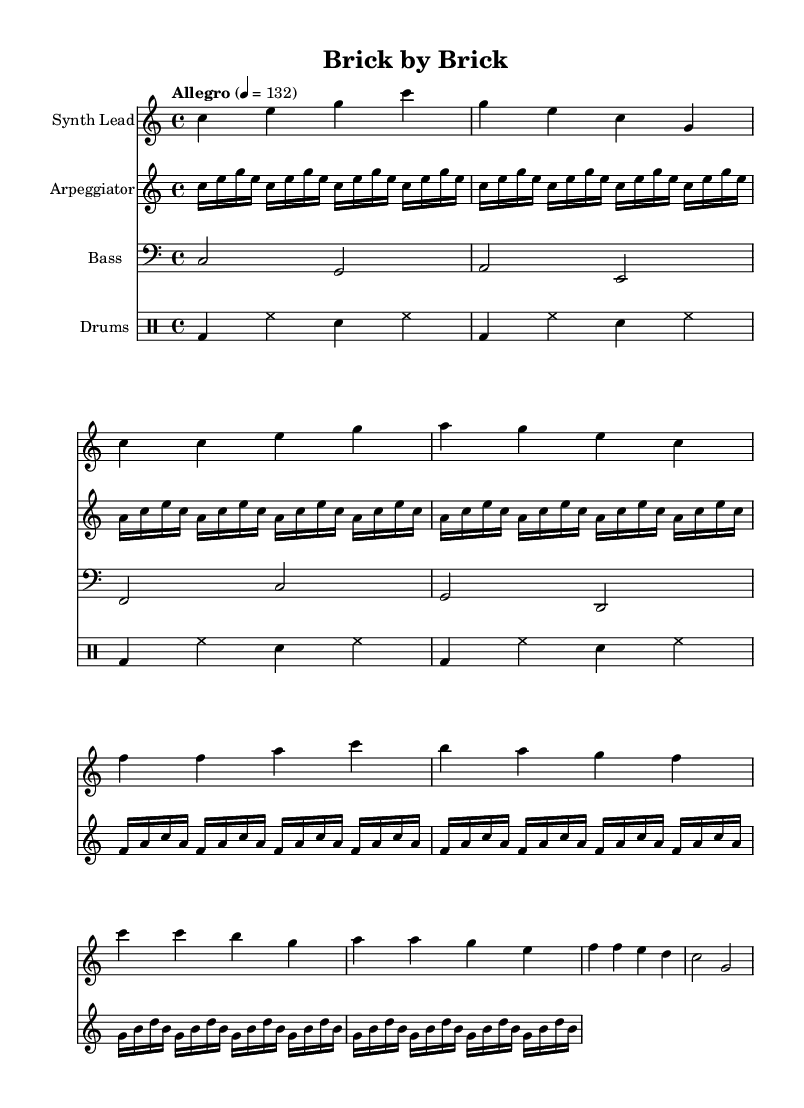What is the key signature of this music? The key signature indicated at the beginning shows no sharps or flats, which defines the key as C major.
Answer: C major What is the time signature of this music? The time signature, shown at the beginning of the sheet music, is 4/4, which means there are four beats in each measure.
Answer: 4/4 What is the tempo marking of this piece? The tempo marking describes the speed of the music, indicated as "Allegro" with a metronome marking of 132 beats per minute.
Answer: Allegro, 132 How many measures are in the synth lead section? By counting the individual measures represented in the synth lead staff, we determine there are 8 measures in that section.
Answer: 8 measures What is the instrument name for the first staff? The first staff is labeled as "Synth Lead," indicating that this part is for a synthesizer instrument.
Answer: Synth Lead Which instrument plays the bassline? The bassline staff is marked with "Bass," indicating this part is specifically written for a bass instrument, usually a bass guitar or synthesizer bass.
Answer: Bass In which section of the music does the rhythm become most pronounced? Observing the drum patterns and their repetition, the rhythm in the "Drums" staff creates a pronounced rhythmic feel throughout the measures, but it is especially prominent during the section where it repeats consistently, marking the verses and chorus.
Answer: Drums section 